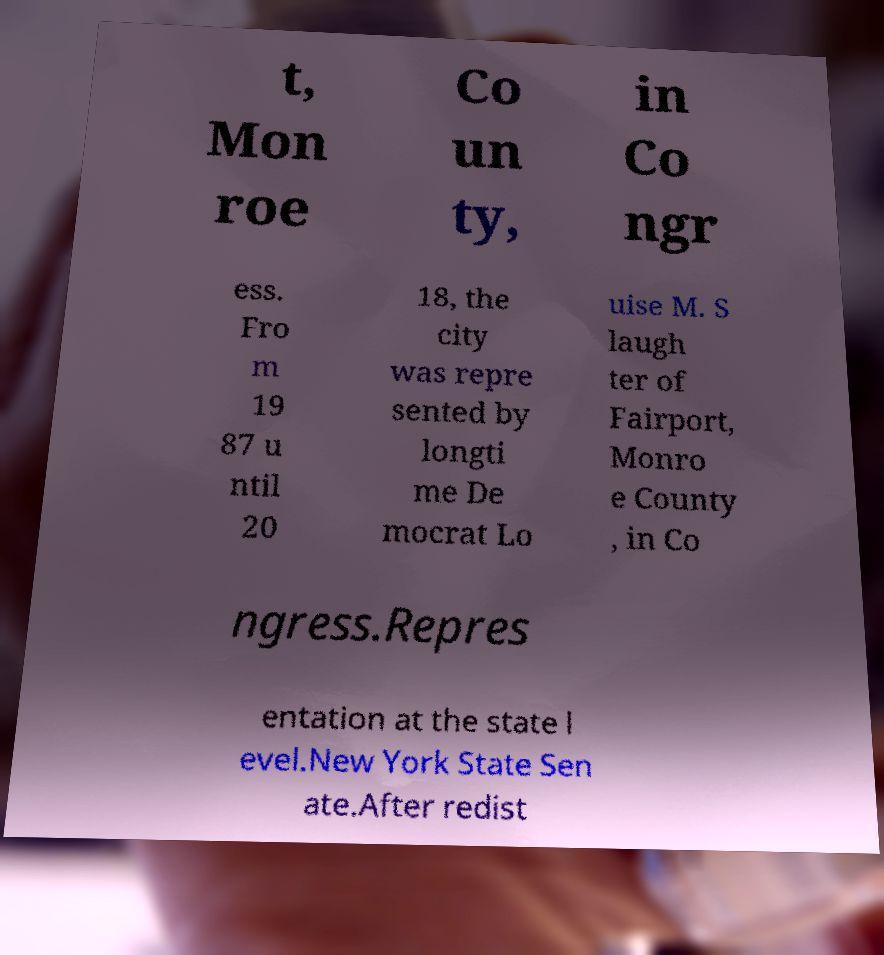Can you read and provide the text displayed in the image?This photo seems to have some interesting text. Can you extract and type it out for me? t, Mon roe Co un ty, in Co ngr ess. Fro m 19 87 u ntil 20 18, the city was repre sented by longti me De mocrat Lo uise M. S laugh ter of Fairport, Monro e County , in Co ngress.Repres entation at the state l evel.New York State Sen ate.After redist 